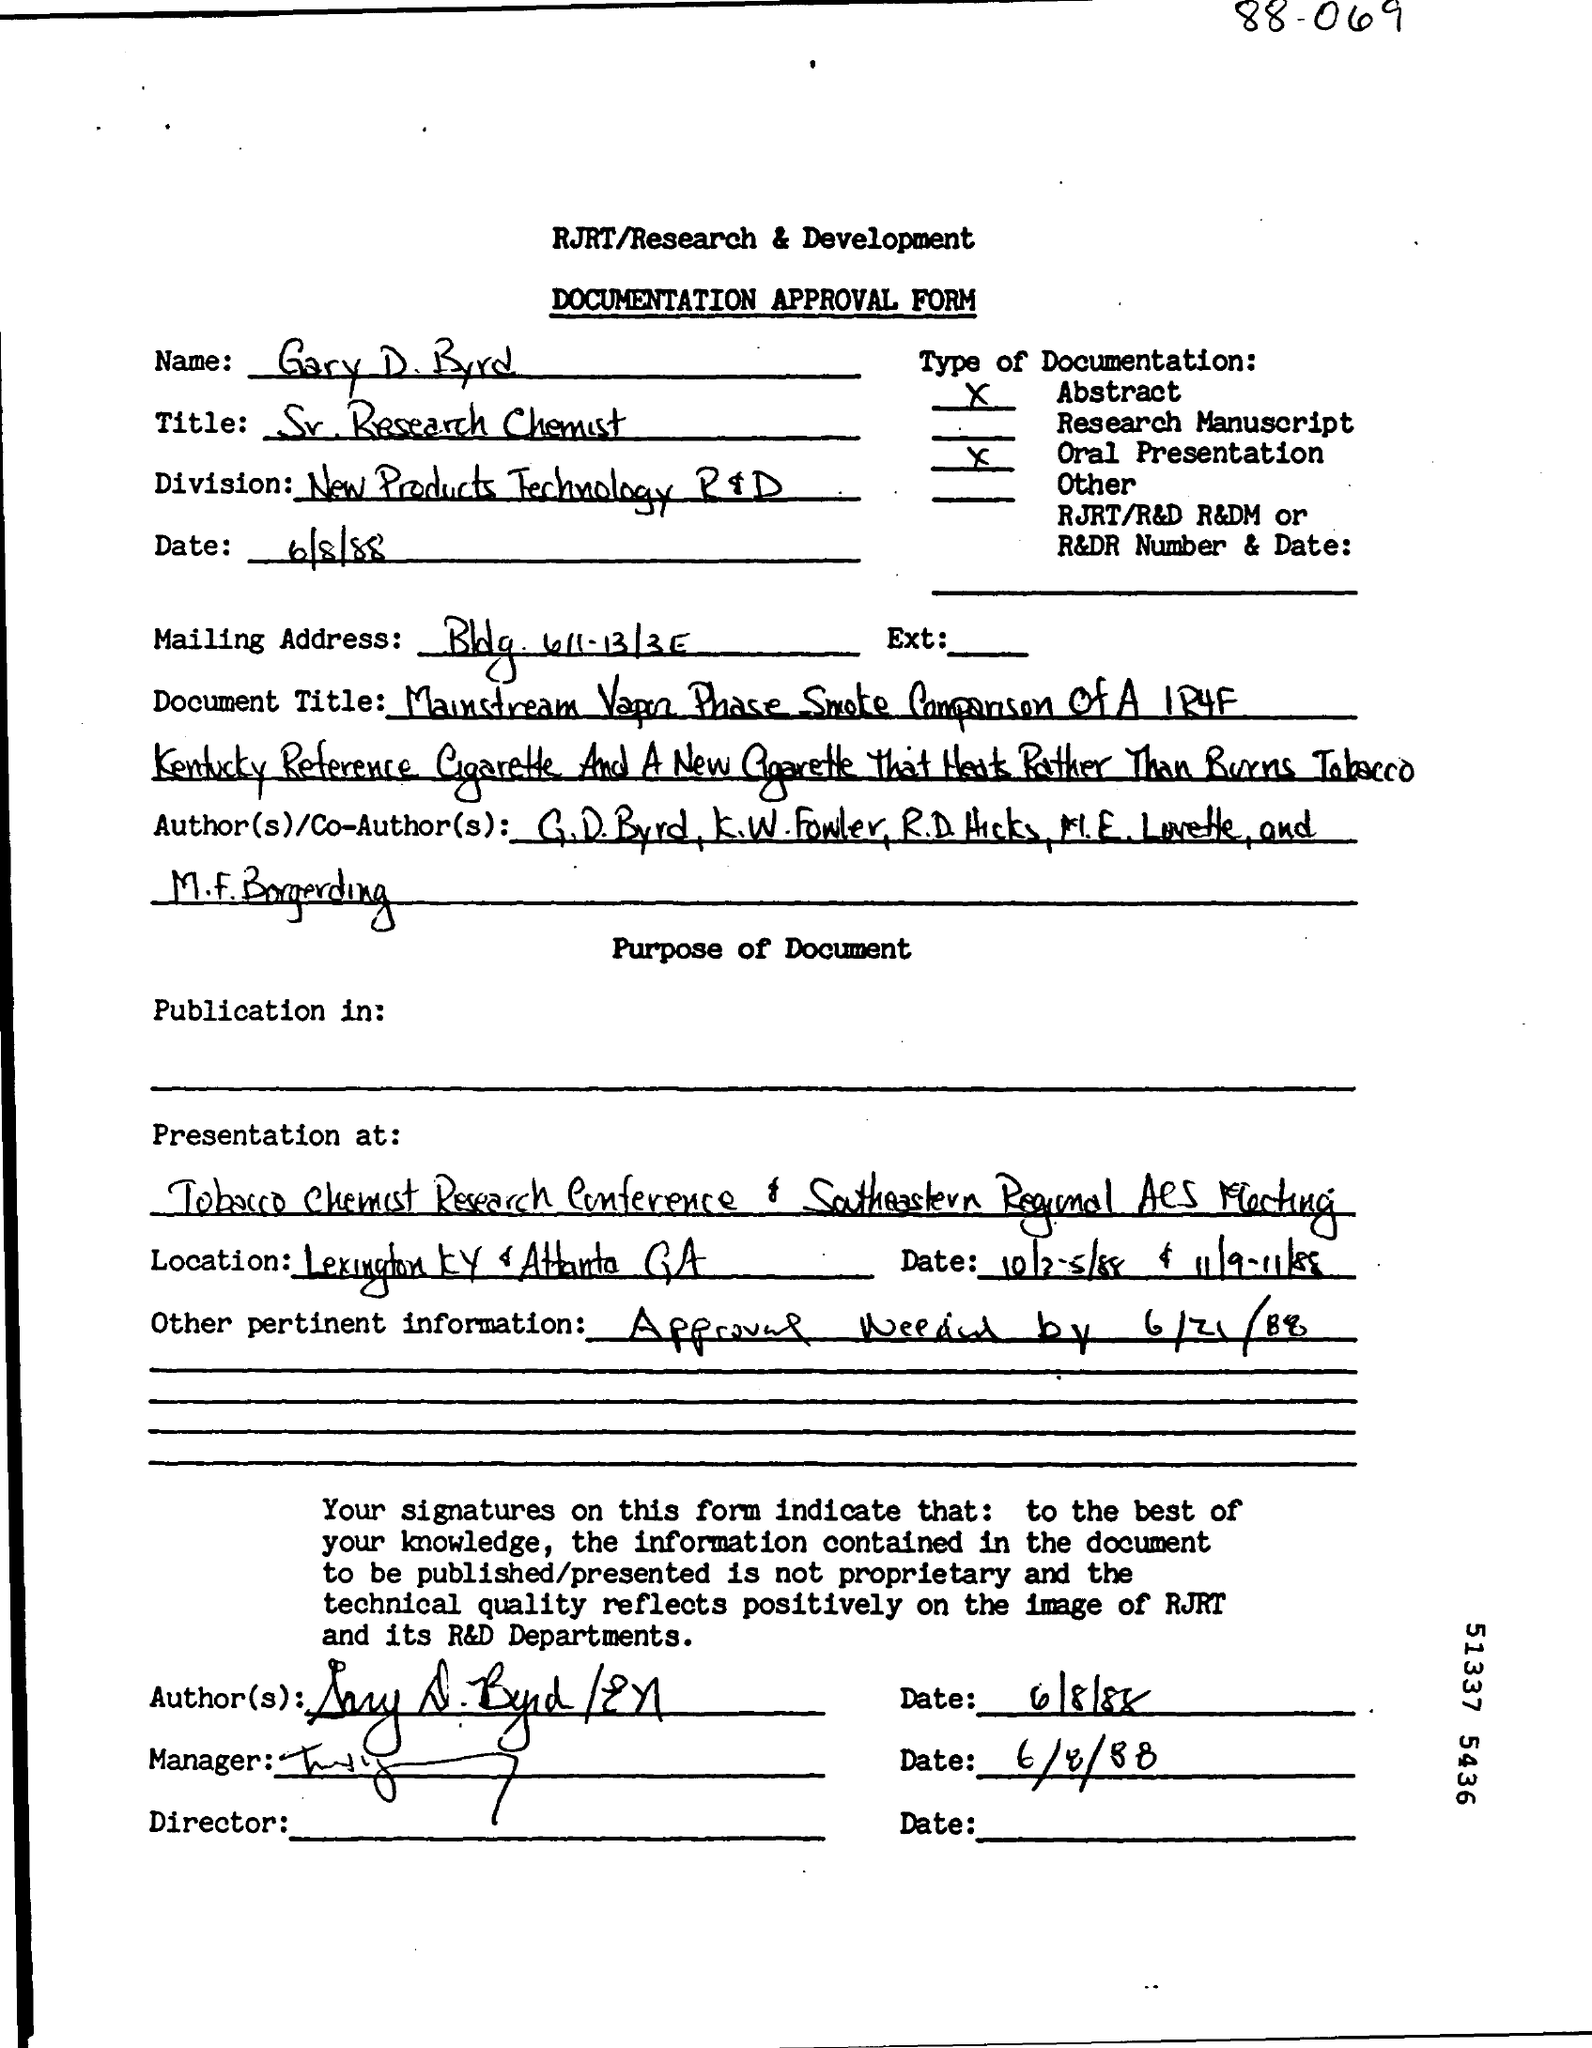What type of form is this?
Keep it short and to the point. DOCUMENTATION APPROVAL FORM. What is the name given?
Your response must be concise. Gary D. Byrd. What is the title of Gary D. Byrd?
Your response must be concise. Sr. research chemist. What other pertinent information is given?
Provide a succinct answer. Approval needed by 6/21/88. 